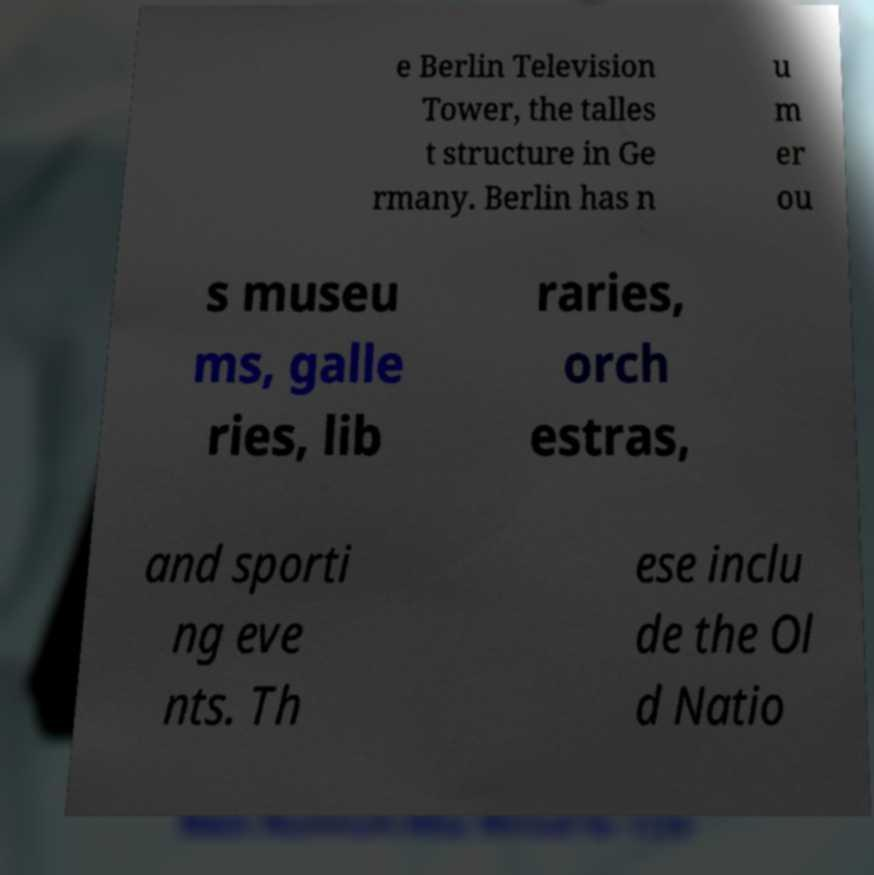Could you extract and type out the text from this image? e Berlin Television Tower, the talles t structure in Ge rmany. Berlin has n u m er ou s museu ms, galle ries, lib raries, orch estras, and sporti ng eve nts. Th ese inclu de the Ol d Natio 